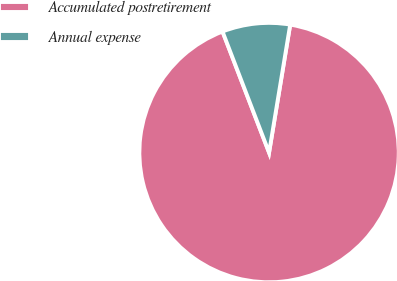Convert chart to OTSL. <chart><loc_0><loc_0><loc_500><loc_500><pie_chart><fcel>Accumulated postretirement<fcel>Annual expense<nl><fcel>91.55%<fcel>8.45%<nl></chart> 